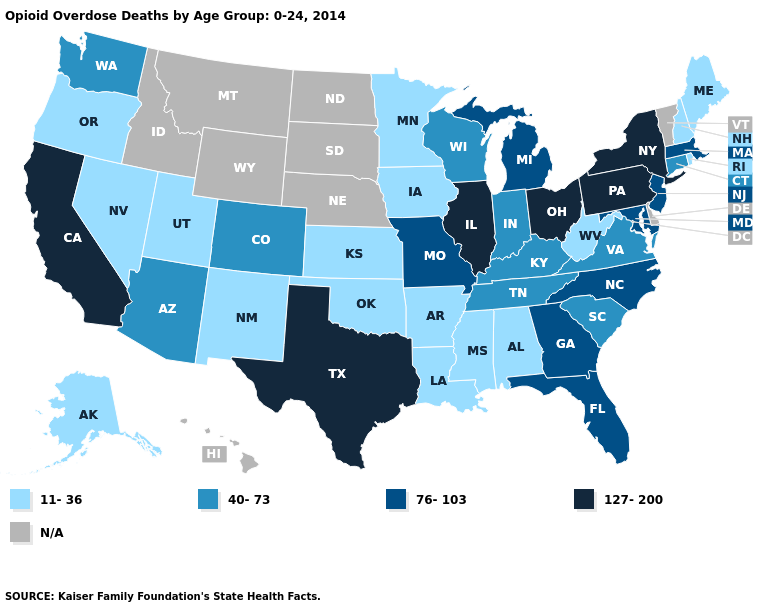Name the states that have a value in the range 127-200?
Short answer required. California, Illinois, New York, Ohio, Pennsylvania, Texas. Name the states that have a value in the range 127-200?
Write a very short answer. California, Illinois, New York, Ohio, Pennsylvania, Texas. What is the highest value in the South ?
Write a very short answer. 127-200. What is the value of New Mexico?
Concise answer only. 11-36. Does South Carolina have the highest value in the South?
Be succinct. No. Which states have the highest value in the USA?
Quick response, please. California, Illinois, New York, Ohio, Pennsylvania, Texas. What is the value of Iowa?
Keep it brief. 11-36. Does Tennessee have the lowest value in the South?
Keep it brief. No. Which states hav the highest value in the MidWest?
Answer briefly. Illinois, Ohio. Does the map have missing data?
Answer briefly. Yes. Among the states that border Arizona , does California have the highest value?
Keep it brief. Yes. Among the states that border Ohio , does Indiana have the highest value?
Short answer required. No. What is the value of New York?
Give a very brief answer. 127-200. Does Virginia have the lowest value in the South?
Write a very short answer. No. Does Illinois have the highest value in the USA?
Keep it brief. Yes. 